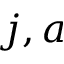<formula> <loc_0><loc_0><loc_500><loc_500>j , a</formula> 